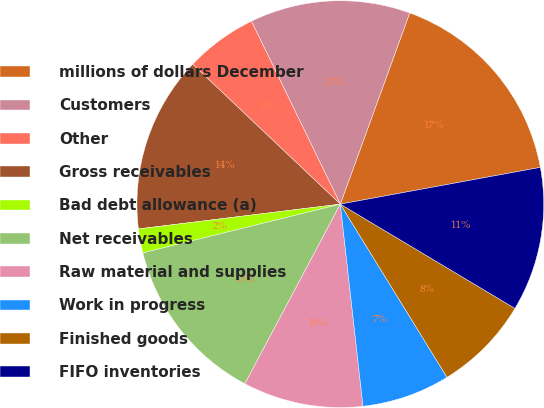Convert chart to OTSL. <chart><loc_0><loc_0><loc_500><loc_500><pie_chart><fcel>millions of dollars December<fcel>Customers<fcel>Other<fcel>Gross receivables<fcel>Bad debt allowance (a)<fcel>Net receivables<fcel>Raw material and supplies<fcel>Work in progress<fcel>Finished goods<fcel>FIFO inventories<nl><fcel>16.56%<fcel>12.74%<fcel>5.73%<fcel>14.01%<fcel>1.91%<fcel>13.37%<fcel>9.55%<fcel>7.01%<fcel>7.64%<fcel>11.46%<nl></chart> 